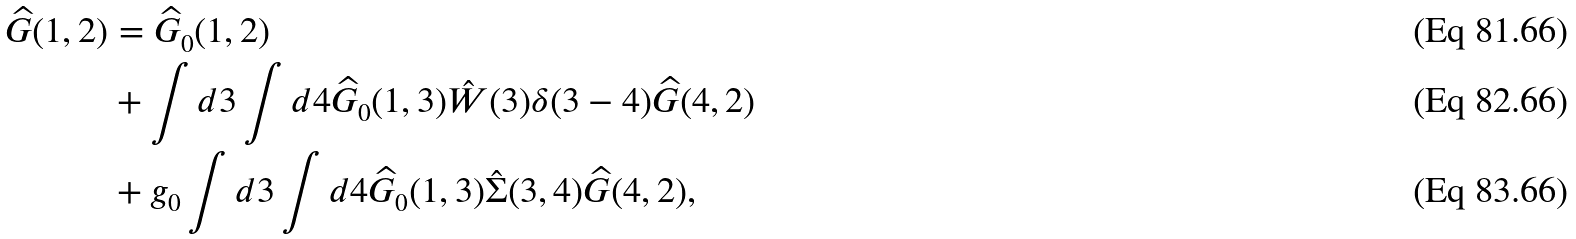<formula> <loc_0><loc_0><loc_500><loc_500>\widehat { G } ( 1 , 2 ) & = \widehat { G } _ { 0 } ( 1 , 2 ) \\ & + \int d 3 \int d 4 \widehat { G } _ { 0 } ( 1 , 3 ) \hat { W } ( 3 ) \delta ( 3 - 4 ) \widehat { G } ( 4 , 2 ) \\ & + g _ { 0 } \int d 3 \int d 4 \widehat { G } _ { 0 } ( 1 , 3 ) \hat { \Sigma } ( 3 , 4 ) \widehat { G } ( 4 , 2 ) ,</formula> 